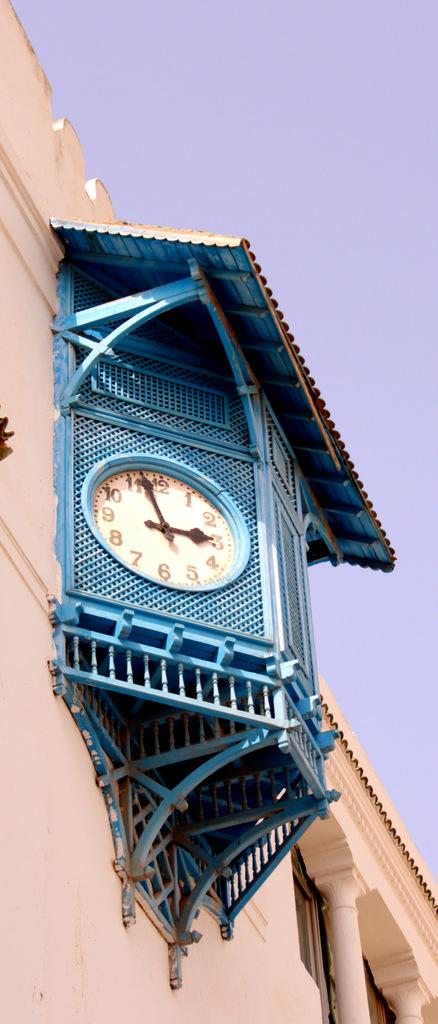<image>
Describe the image concisely. White clock with the hands on the 3 and 11 on a blue building. 